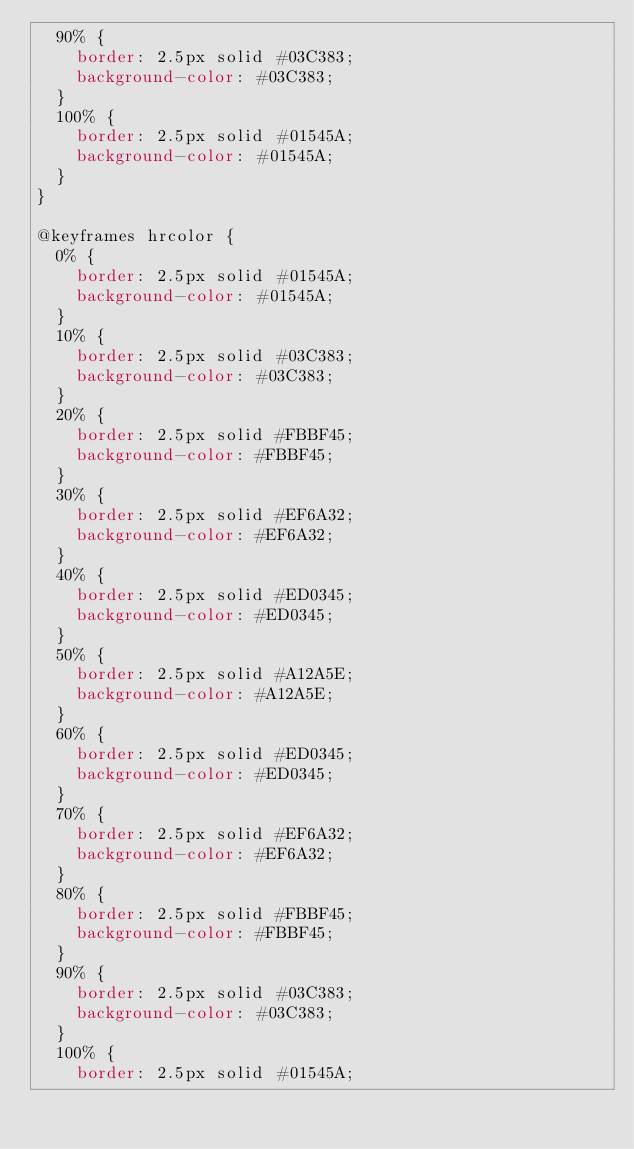Convert code to text. <code><loc_0><loc_0><loc_500><loc_500><_CSS_>  90% {
    border: 2.5px solid #03C383;
    background-color: #03C383;
  }
  100% {
    border: 2.5px solid #01545A;
    background-color: #01545A;
  }
}

@keyframes hrcolor {
  0% {
    border: 2.5px solid #01545A;
    background-color: #01545A;
  }
  10% {
    border: 2.5px solid #03C383;
    background-color: #03C383;
  }
  20% {
    border: 2.5px solid #FBBF45;
    background-color: #FBBF45;
  }
  30% {
    border: 2.5px solid #EF6A32;
    background-color: #EF6A32;
  }
  40% {
    border: 2.5px solid #ED0345;
    background-color: #ED0345;
  }
  50% {
    border: 2.5px solid #A12A5E;
    background-color: #A12A5E;
  }
  60% {
    border: 2.5px solid #ED0345;
    background-color: #ED0345;
  }
  70% {
    border: 2.5px solid #EF6A32;
    background-color: #EF6A32;
  }
  80% {
    border: 2.5px solid #FBBF45;
    background-color: #FBBF45;
  }
  90% {
    border: 2.5px solid #03C383;
    background-color: #03C383;
  }
  100% {
    border: 2.5px solid #01545A;</code> 